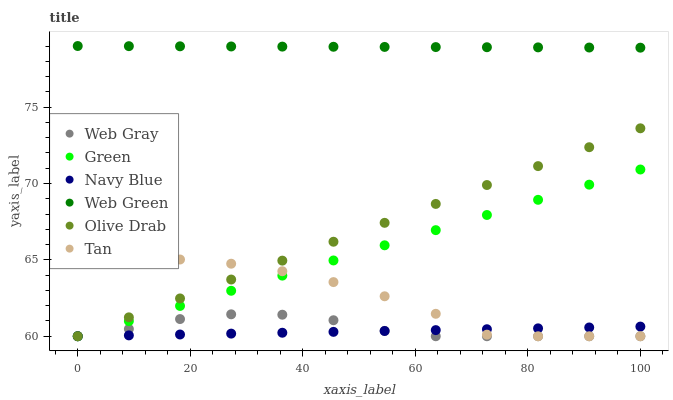Does Navy Blue have the minimum area under the curve?
Answer yes or no. Yes. Does Web Green have the maximum area under the curve?
Answer yes or no. Yes. Does Web Green have the minimum area under the curve?
Answer yes or no. No. Does Navy Blue have the maximum area under the curve?
Answer yes or no. No. Is Olive Drab the smoothest?
Answer yes or no. Yes. Is Tan the roughest?
Answer yes or no. Yes. Is Navy Blue the smoothest?
Answer yes or no. No. Is Navy Blue the roughest?
Answer yes or no. No. Does Web Gray have the lowest value?
Answer yes or no. Yes. Does Web Green have the lowest value?
Answer yes or no. No. Does Web Green have the highest value?
Answer yes or no. Yes. Does Navy Blue have the highest value?
Answer yes or no. No. Is Olive Drab less than Web Green?
Answer yes or no. Yes. Is Web Green greater than Green?
Answer yes or no. Yes. Does Navy Blue intersect Tan?
Answer yes or no. Yes. Is Navy Blue less than Tan?
Answer yes or no. No. Is Navy Blue greater than Tan?
Answer yes or no. No. Does Olive Drab intersect Web Green?
Answer yes or no. No. 